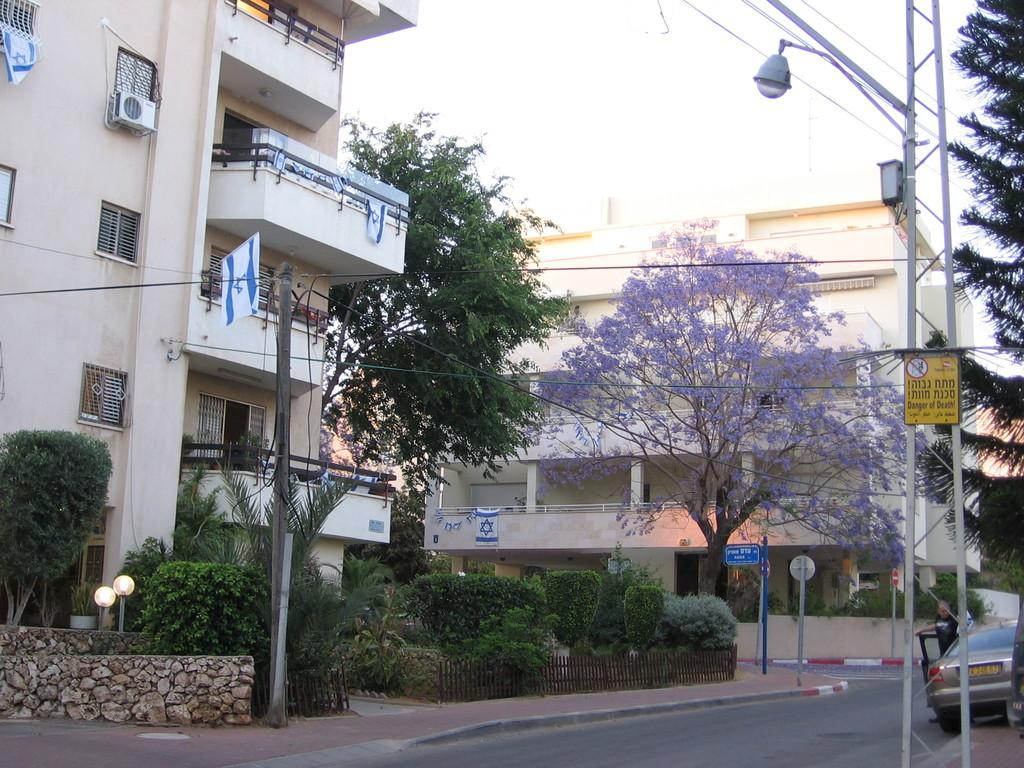What structures are present in the image? There are poles in the image. What type of vegetation can be seen in the image? There are plants and trees in the image. What type of informational or directional objects are present in the image? There are sign boards in the image. What type of man-made structures are visible in the background of the image? There are buildings visible in the background of the image. What type of transportation objects are present in the image? There are vehicles in the image. Can you describe the position of the man in the image? A man is standing behind a vehicle in the image. What type of punishment is being administered to the plants in the image? There is no punishment being administered to the plants in the image; they are simply growing. How many steps are visible in the image? There is no mention of steps in the image, so it is impossible to determine the number of steps present. 